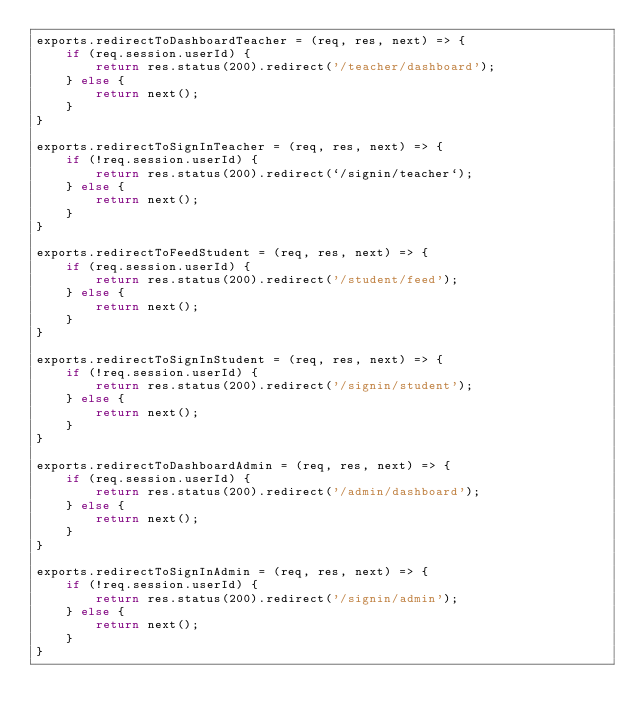<code> <loc_0><loc_0><loc_500><loc_500><_JavaScript_>exports.redirectToDashboardTeacher = (req, res, next) => {
    if (req.session.userId) {
        return res.status(200).redirect('/teacher/dashboard');
    } else {
        return next();
    }
}

exports.redirectToSignInTeacher = (req, res, next) => {
    if (!req.session.userId) {
        return res.status(200).redirect(`/signin/teacher`);
    } else {
        return next();
    }
}

exports.redirectToFeedStudent = (req, res, next) => {
    if (req.session.userId) {
        return res.status(200).redirect('/student/feed');
    } else {
        return next();
    }
}

exports.redirectToSignInStudent = (req, res, next) => {
    if (!req.session.userId) {
        return res.status(200).redirect('/signin/student');
    } else {
        return next();
    }
}

exports.redirectToDashboardAdmin = (req, res, next) => {
    if (req.session.userId) {
        return res.status(200).redirect('/admin/dashboard');
    } else {
        return next();
    }
}

exports.redirectToSignInAdmin = (req, res, next) => {
    if (!req.session.userId) {
        return res.status(200).redirect('/signin/admin');
    } else {
        return next();
    }
}</code> 